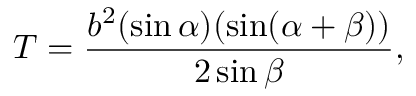Convert formula to latex. <formula><loc_0><loc_0><loc_500><loc_500>T = { \frac { b ^ { 2 } ( \sin \alpha ) ( \sin ( \alpha + \beta ) ) } { 2 \sin \beta } } ,</formula> 